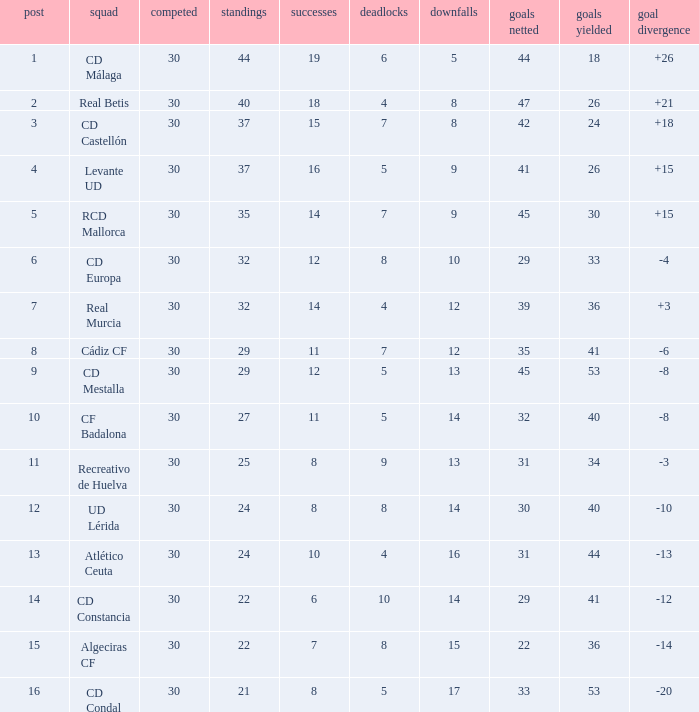What is the wins number when the points were smaller than 27, and goals against was 41? 6.0. 